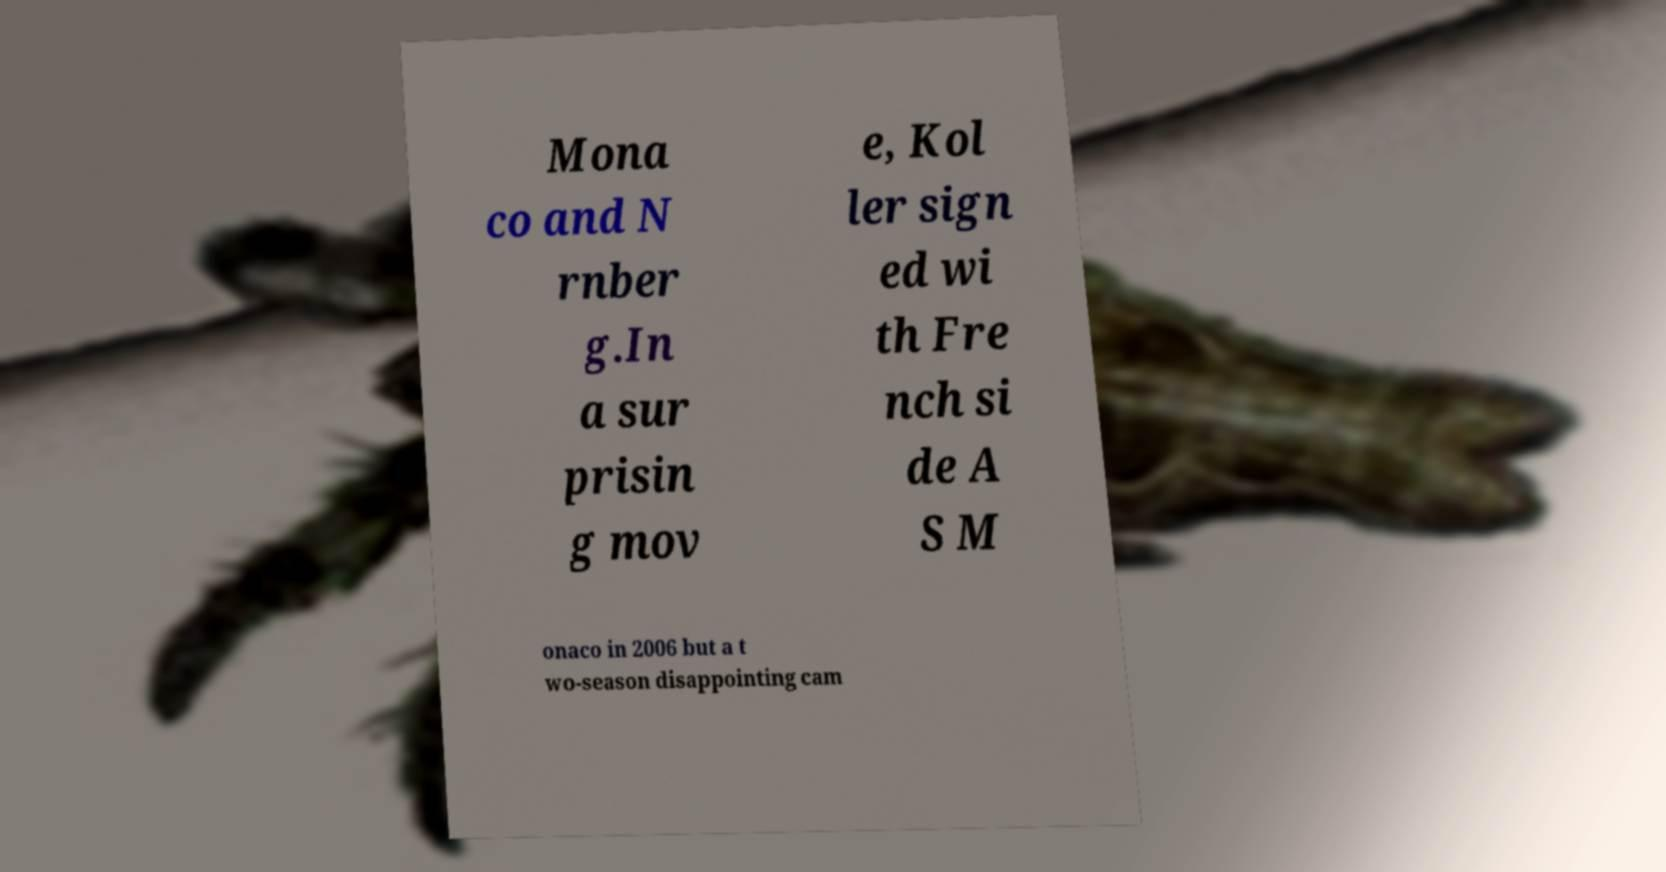What messages or text are displayed in this image? I need them in a readable, typed format. Mona co and N rnber g.In a sur prisin g mov e, Kol ler sign ed wi th Fre nch si de A S M onaco in 2006 but a t wo-season disappointing cam 